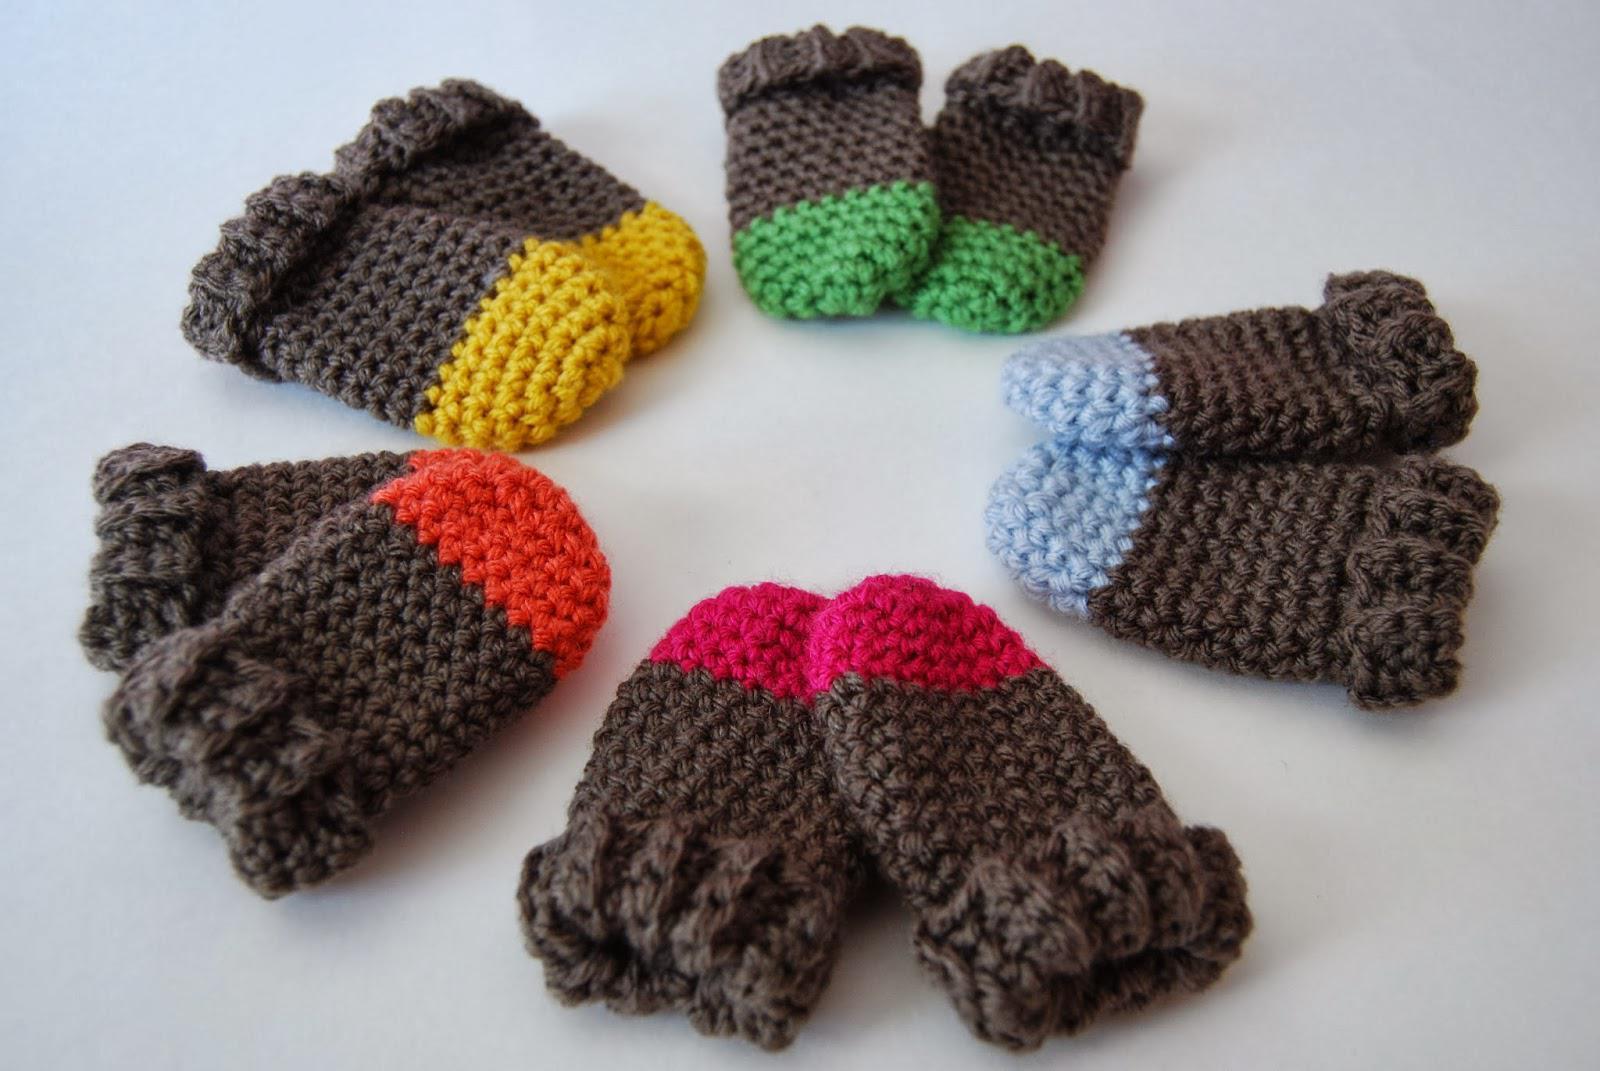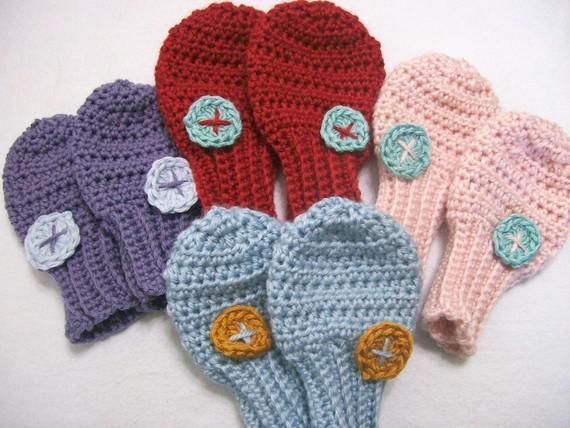The first image is the image on the left, the second image is the image on the right. Considering the images on both sides, is "Each image contains at least two baby mittens, and no mittens have separate thumb sections." valid? Answer yes or no. Yes. The first image is the image on the left, the second image is the image on the right. For the images shown, is this caption "There are at least 3 pairs of mittens all a different color." true? Answer yes or no. Yes. 